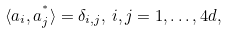Convert formula to latex. <formula><loc_0><loc_0><loc_500><loc_500>\langle a _ { i } , a _ { j } ^ { ^ { * } } \rangle = \delta _ { i , j } , \, i , j = 1 , \dots , 4 d ,</formula> 